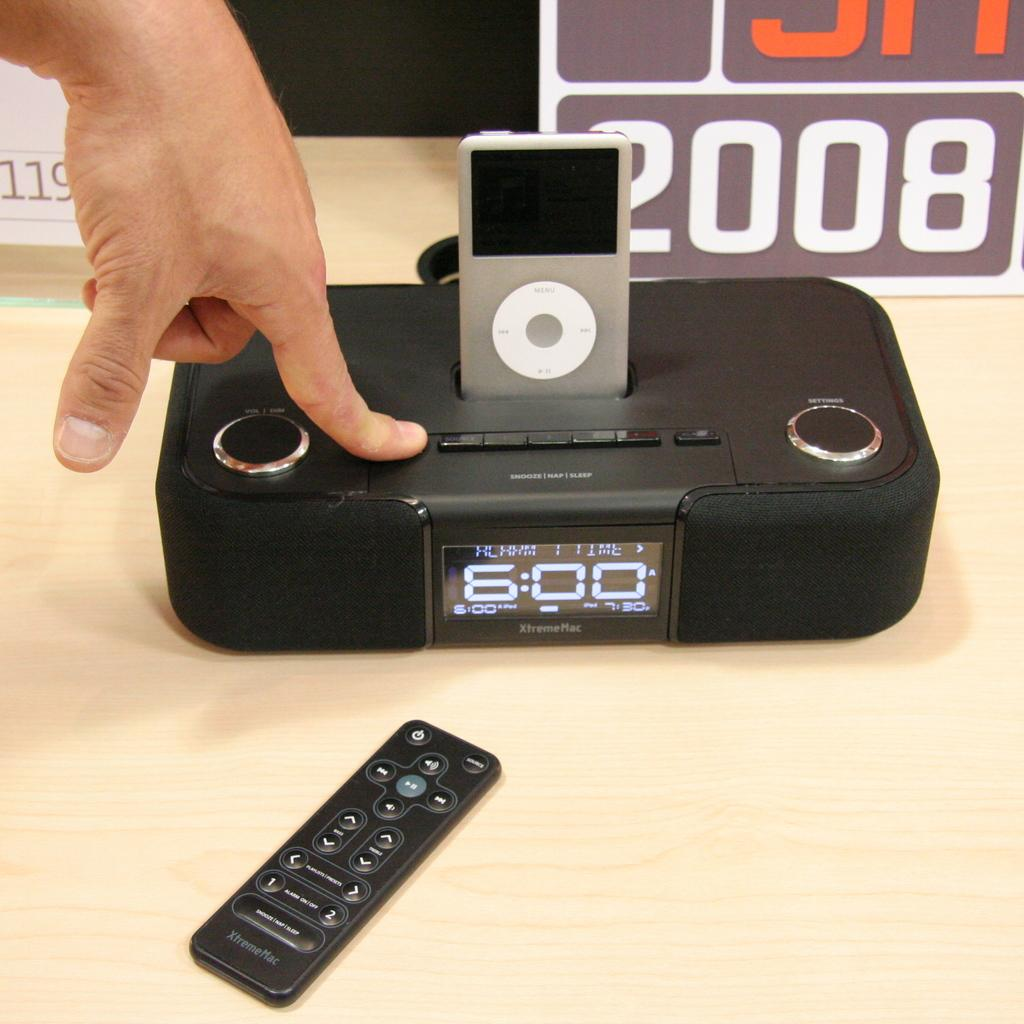<image>
Render a clear and concise summary of the photo. hand on an xtrememac clock radio with ipod holder 